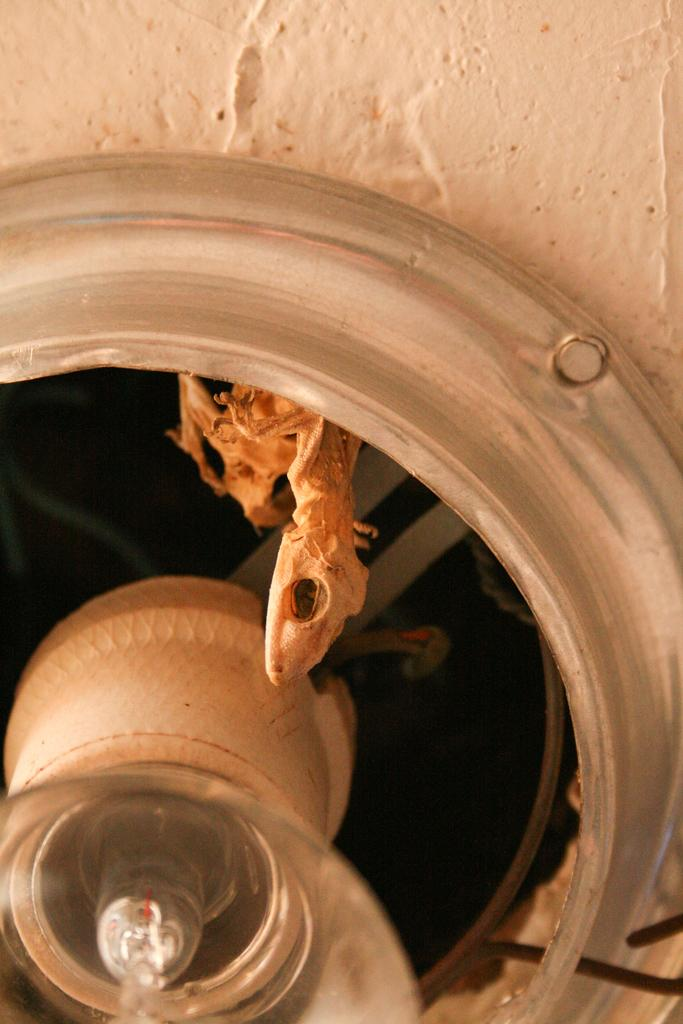What is the main subject of the image? The main subject of the image is a lizard skeleton. What other objects can be seen in the image? There is a bulb holder with a bulb and a circular object on a wall in the image. Where is the bulb holder located in the image? The bulb holder is in the left bottom corner of the image. What type of corn is being attacked by the lizard in the image? There is no corn or lizard present in the image; it features a lizard skeleton and other objects. What type of office equipment can be seen in the image? There is no office equipment present in the image. 